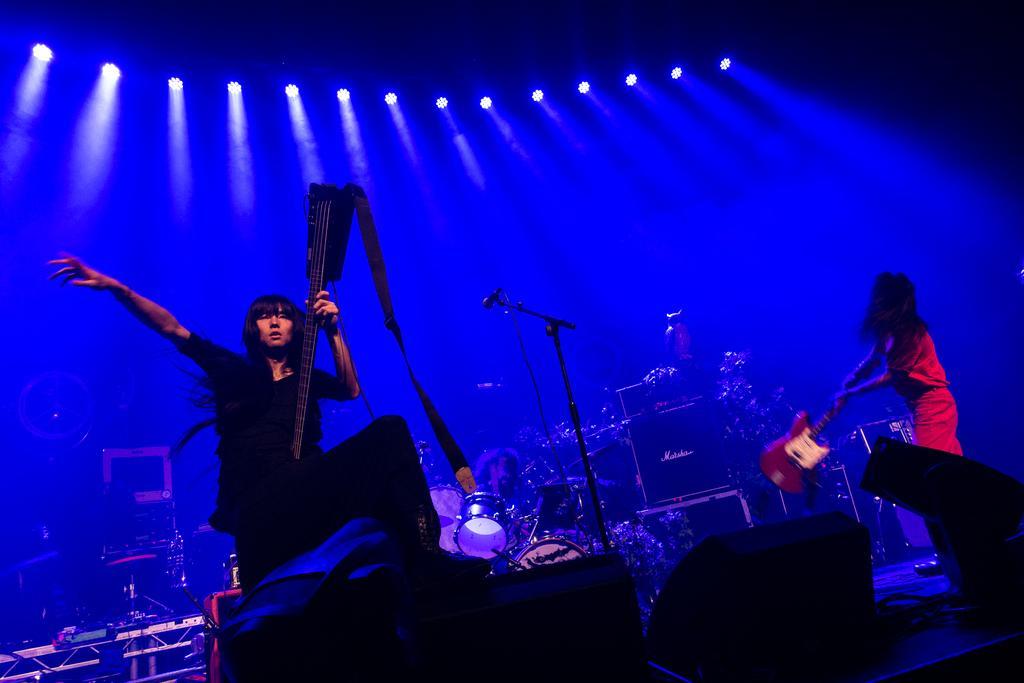Could you give a brief overview of what you see in this image? In this picture we can see two women carrying guitar with their hands and in between them we can see person playing drums, mic stand, lights and some musical instruments. 